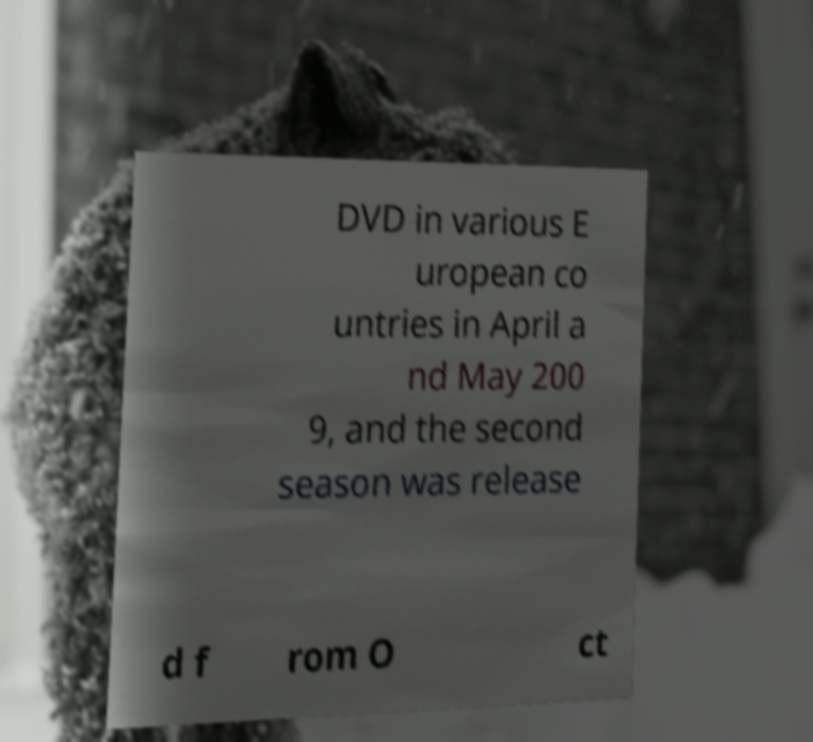For documentation purposes, I need the text within this image transcribed. Could you provide that? DVD in various E uropean co untries in April a nd May 200 9, and the second season was release d f rom O ct 